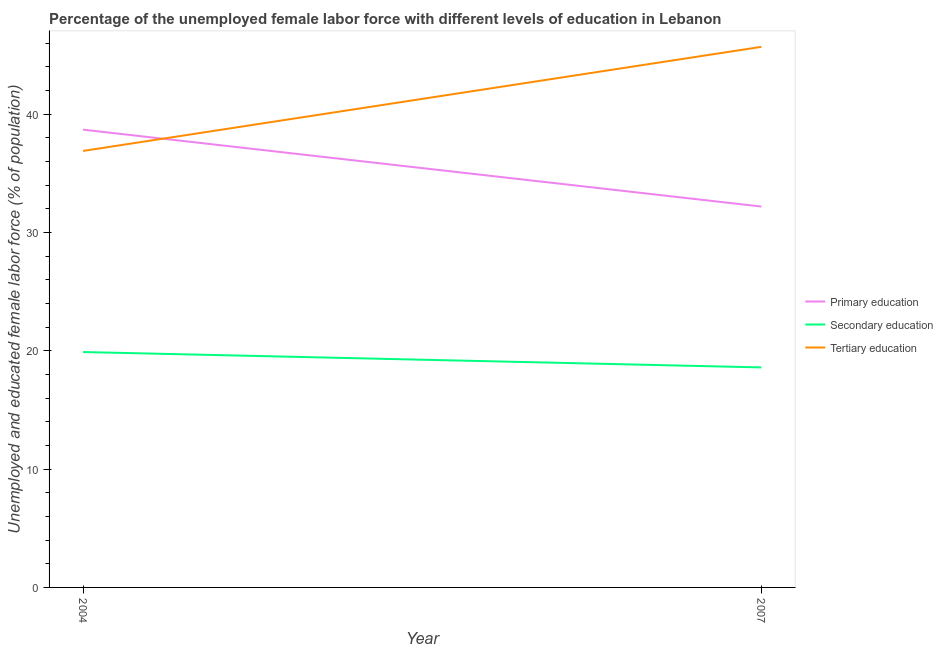Does the line corresponding to percentage of female labor force who received secondary education intersect with the line corresponding to percentage of female labor force who received tertiary education?
Make the answer very short. No. Is the number of lines equal to the number of legend labels?
Make the answer very short. Yes. What is the percentage of female labor force who received primary education in 2007?
Offer a terse response. 32.2. Across all years, what is the maximum percentage of female labor force who received tertiary education?
Make the answer very short. 45.7. Across all years, what is the minimum percentage of female labor force who received tertiary education?
Provide a succinct answer. 36.9. In which year was the percentage of female labor force who received secondary education minimum?
Your answer should be compact. 2007. What is the total percentage of female labor force who received primary education in the graph?
Provide a succinct answer. 70.9. What is the difference between the percentage of female labor force who received tertiary education in 2004 and that in 2007?
Provide a succinct answer. -8.8. What is the difference between the percentage of female labor force who received secondary education in 2007 and the percentage of female labor force who received tertiary education in 2004?
Offer a terse response. -18.3. What is the average percentage of female labor force who received tertiary education per year?
Provide a succinct answer. 41.3. In the year 2004, what is the difference between the percentage of female labor force who received primary education and percentage of female labor force who received tertiary education?
Your answer should be very brief. 1.8. In how many years, is the percentage of female labor force who received tertiary education greater than 6 %?
Give a very brief answer. 2. What is the ratio of the percentage of female labor force who received secondary education in 2004 to that in 2007?
Keep it short and to the point. 1.07. Is the percentage of female labor force who received tertiary education in 2004 less than that in 2007?
Keep it short and to the point. Yes. In how many years, is the percentage of female labor force who received primary education greater than the average percentage of female labor force who received primary education taken over all years?
Offer a very short reply. 1. Is the percentage of female labor force who received tertiary education strictly greater than the percentage of female labor force who received secondary education over the years?
Ensure brevity in your answer.  Yes. Is the percentage of female labor force who received tertiary education strictly less than the percentage of female labor force who received primary education over the years?
Provide a succinct answer. No. What is the difference between two consecutive major ticks on the Y-axis?
Provide a succinct answer. 10. Are the values on the major ticks of Y-axis written in scientific E-notation?
Offer a very short reply. No. Does the graph contain any zero values?
Keep it short and to the point. No. Does the graph contain grids?
Ensure brevity in your answer.  No. How are the legend labels stacked?
Ensure brevity in your answer.  Vertical. What is the title of the graph?
Give a very brief answer. Percentage of the unemployed female labor force with different levels of education in Lebanon. What is the label or title of the X-axis?
Offer a terse response. Year. What is the label or title of the Y-axis?
Give a very brief answer. Unemployed and educated female labor force (% of population). What is the Unemployed and educated female labor force (% of population) in Primary education in 2004?
Your answer should be very brief. 38.7. What is the Unemployed and educated female labor force (% of population) of Secondary education in 2004?
Your answer should be very brief. 19.9. What is the Unemployed and educated female labor force (% of population) in Tertiary education in 2004?
Ensure brevity in your answer.  36.9. What is the Unemployed and educated female labor force (% of population) of Primary education in 2007?
Make the answer very short. 32.2. What is the Unemployed and educated female labor force (% of population) in Secondary education in 2007?
Provide a succinct answer. 18.6. What is the Unemployed and educated female labor force (% of population) of Tertiary education in 2007?
Give a very brief answer. 45.7. Across all years, what is the maximum Unemployed and educated female labor force (% of population) in Primary education?
Offer a terse response. 38.7. Across all years, what is the maximum Unemployed and educated female labor force (% of population) of Secondary education?
Your answer should be compact. 19.9. Across all years, what is the maximum Unemployed and educated female labor force (% of population) in Tertiary education?
Keep it short and to the point. 45.7. Across all years, what is the minimum Unemployed and educated female labor force (% of population) in Primary education?
Ensure brevity in your answer.  32.2. Across all years, what is the minimum Unemployed and educated female labor force (% of population) of Secondary education?
Provide a succinct answer. 18.6. Across all years, what is the minimum Unemployed and educated female labor force (% of population) in Tertiary education?
Ensure brevity in your answer.  36.9. What is the total Unemployed and educated female labor force (% of population) of Primary education in the graph?
Make the answer very short. 70.9. What is the total Unemployed and educated female labor force (% of population) of Secondary education in the graph?
Offer a very short reply. 38.5. What is the total Unemployed and educated female labor force (% of population) of Tertiary education in the graph?
Keep it short and to the point. 82.6. What is the difference between the Unemployed and educated female labor force (% of population) in Primary education in 2004 and that in 2007?
Your answer should be compact. 6.5. What is the difference between the Unemployed and educated female labor force (% of population) of Secondary education in 2004 and that in 2007?
Offer a terse response. 1.3. What is the difference between the Unemployed and educated female labor force (% of population) of Primary education in 2004 and the Unemployed and educated female labor force (% of population) of Secondary education in 2007?
Offer a terse response. 20.1. What is the difference between the Unemployed and educated female labor force (% of population) of Primary education in 2004 and the Unemployed and educated female labor force (% of population) of Tertiary education in 2007?
Give a very brief answer. -7. What is the difference between the Unemployed and educated female labor force (% of population) of Secondary education in 2004 and the Unemployed and educated female labor force (% of population) of Tertiary education in 2007?
Offer a terse response. -25.8. What is the average Unemployed and educated female labor force (% of population) of Primary education per year?
Provide a succinct answer. 35.45. What is the average Unemployed and educated female labor force (% of population) of Secondary education per year?
Offer a terse response. 19.25. What is the average Unemployed and educated female labor force (% of population) of Tertiary education per year?
Your answer should be compact. 41.3. In the year 2004, what is the difference between the Unemployed and educated female labor force (% of population) in Primary education and Unemployed and educated female labor force (% of population) in Secondary education?
Give a very brief answer. 18.8. In the year 2004, what is the difference between the Unemployed and educated female labor force (% of population) in Primary education and Unemployed and educated female labor force (% of population) in Tertiary education?
Your answer should be compact. 1.8. In the year 2004, what is the difference between the Unemployed and educated female labor force (% of population) of Secondary education and Unemployed and educated female labor force (% of population) of Tertiary education?
Provide a short and direct response. -17. In the year 2007, what is the difference between the Unemployed and educated female labor force (% of population) of Secondary education and Unemployed and educated female labor force (% of population) of Tertiary education?
Provide a succinct answer. -27.1. What is the ratio of the Unemployed and educated female labor force (% of population) in Primary education in 2004 to that in 2007?
Your answer should be compact. 1.2. What is the ratio of the Unemployed and educated female labor force (% of population) of Secondary education in 2004 to that in 2007?
Keep it short and to the point. 1.07. What is the ratio of the Unemployed and educated female labor force (% of population) in Tertiary education in 2004 to that in 2007?
Your answer should be very brief. 0.81. What is the difference between the highest and the second highest Unemployed and educated female labor force (% of population) of Primary education?
Your response must be concise. 6.5. 